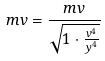Convert formula to latex. <formula><loc_0><loc_0><loc_500><loc_500>m v = \frac { m v } { \sqrt { 1 \cdot \frac { v ^ { 4 } } { y ^ { 4 } } } }</formula> 